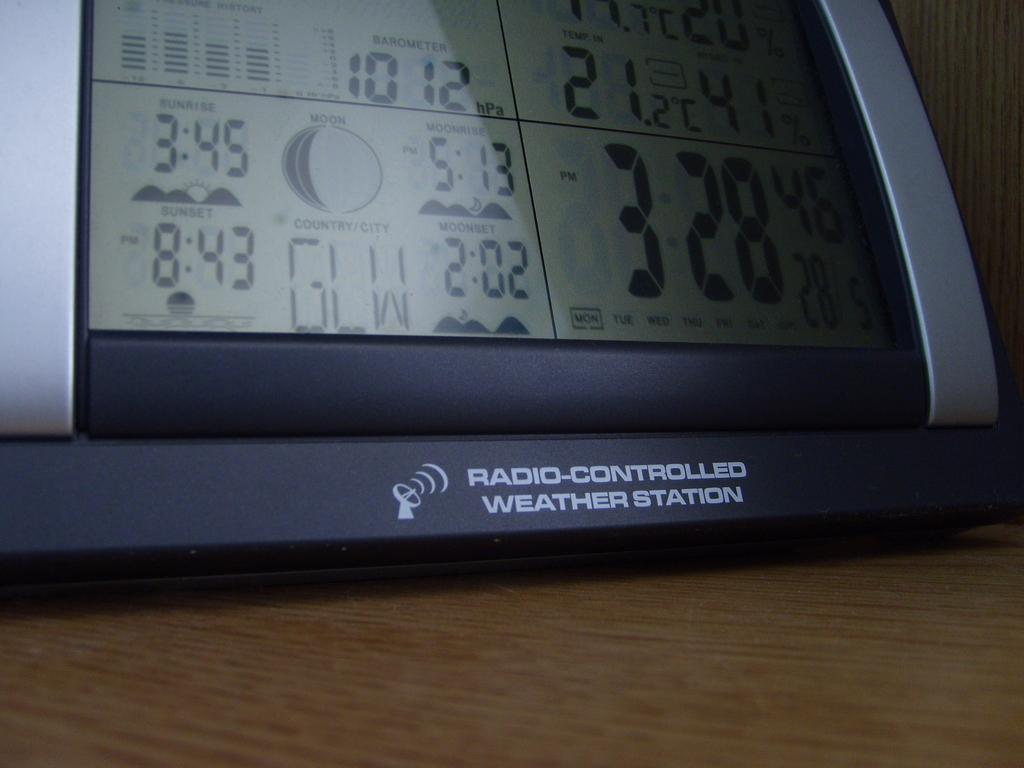<image>
Provide a brief description of the given image. A radio controlled weather station displaying the sunset time of 8:43 